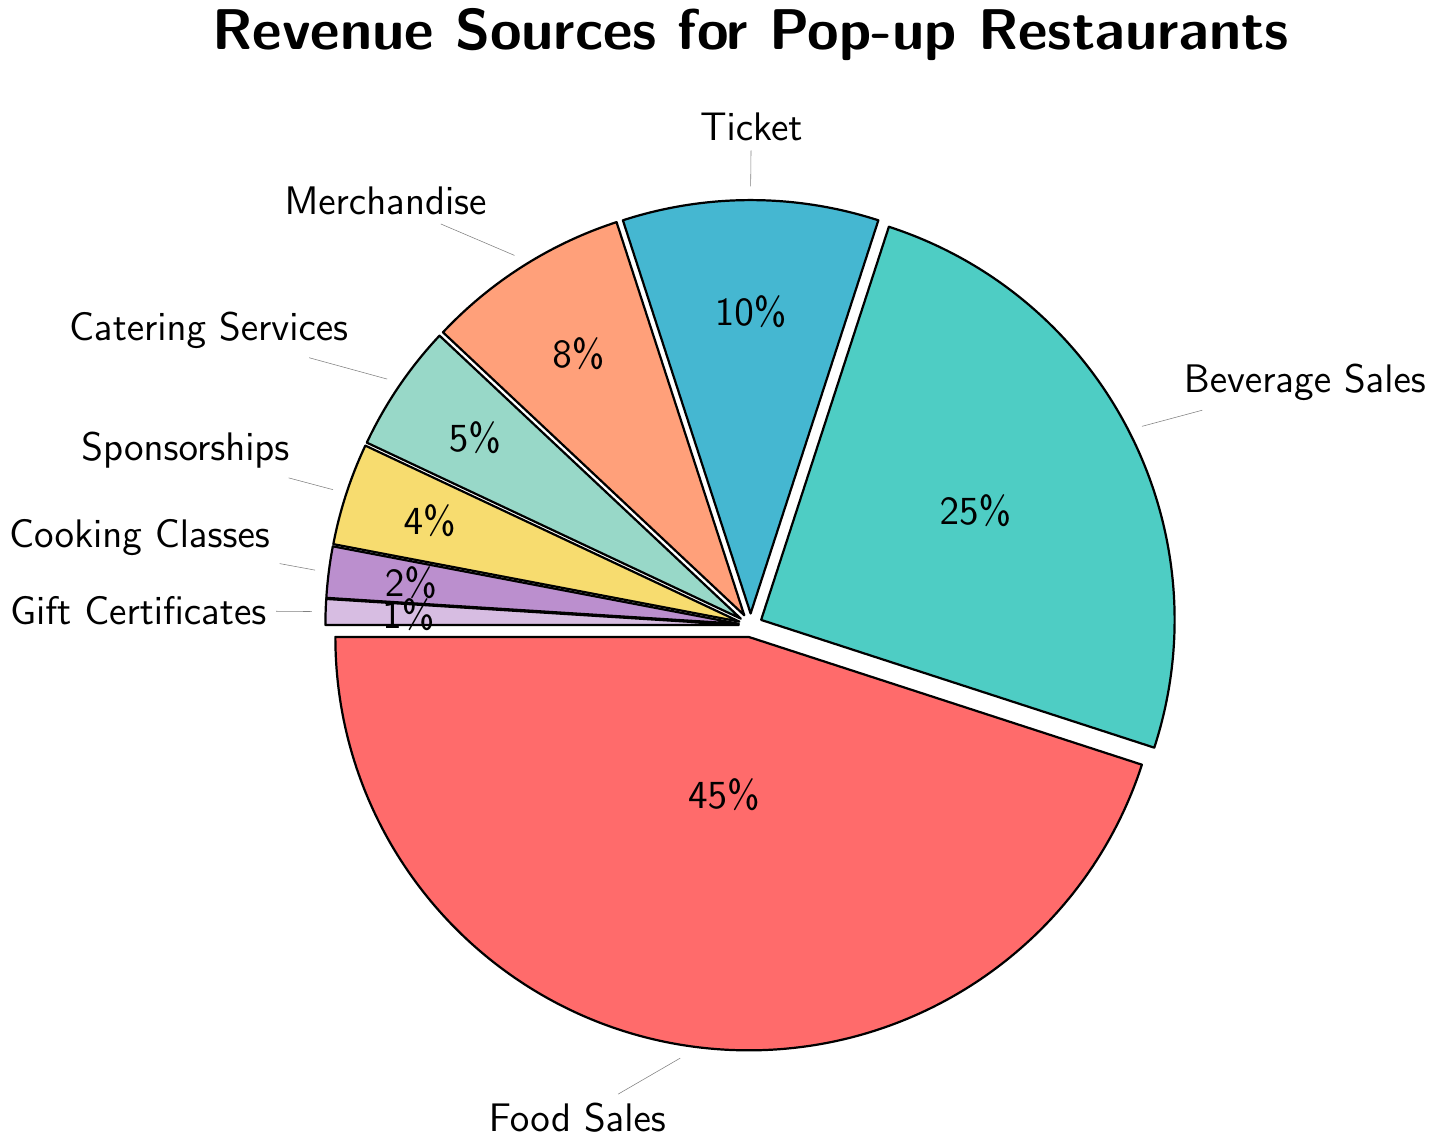Which revenue source contributes the most? The largest segment in the pie chart is labeled "Food Sales" and takes up 45% of the chart, indicating it's the highest contributor.
Answer: Food Sales What percentage of revenue comes from Sponsorships and Cooking Classes combined? The segments "Sponsorships" and "Cooking Classes" contribute 4% and 2% respectively, so the combined percentage is 4% + 2% = 6%.
Answer: 6% How much more percentage does Beverage Sales contribute compared to Merchandise? Beverage Sales contributes 25% and Merchandise contributes 8%. The difference is 25% - 8% = 17%.
Answer: 17% Which revenue source contributes the least and what is its percentage? The smallest segment in the pie chart is labeled "Gift Certificates" and it takes up 1% of the chart, indicating it's the least contributor.
Answer: Gift Certificates, 1% Is the percentage of revenue from Catering Services more than double the percentage of revenue from Cooking Classes? Catering Services constitutes 5% and Cooking Classes make up 2%. Double the percentage of Cooking Classes would be 2% * 2 = 4%. Since 5% > 4%, Catering Services contributes more than double the revenue of Cooking Classes.
Answer: Yes Are the combined revenues from Merchandise and Catering Services higher than the revenue from Ticket/Entry Fees? Merchandise contributes 8% and Catering Services 5%, so combined they are 8% + 5% = 13%. Ticket/Entry Fees contributes 10%, and 13% > 10%, hence combined they are higher.
Answer: Yes Which segment has the lightest color and what is the revenue percentage for that segment? The lightest colored segment in the pie chart is "Gift Certificates," which contributes 1% to the total revenue.
Answer: Gift Certificates, 1% What is the total percentage of revenue from all sources except Food Sales and Beverage Sales? All other sources (excluding Food Sales and Beverage Sales) are Ticket/Entry Fees (10%), Merchandise (8%), Catering Services (5%), Sponsorships (4%), Cooking Classes (2%), and Gift Certificates (1%). Summing them up gives 10% + 8% + 5% + 4% + 2% + 1% = 30%.
Answer: 30% By how much does the revenue from Food Sales exceed the sum of Catering Services and Sponsorships? Food Sales contributes 45%. Catering Services and Sponsorships add up to 5% + 4% = 9%. The excess is 45% - 9% = 36%.
Answer: 36% What is the combined revenue percentage from the three smallest revenue sources? The three smallest sources are Gift Certificates (1%), Cooking Classes (2%), and Sponsorships (4%). Summing these up gives 1% + 2% + 4% = 7%.
Answer: 7% 